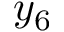Convert formula to latex. <formula><loc_0><loc_0><loc_500><loc_500>y _ { 6 }</formula> 